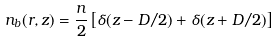Convert formula to latex. <formula><loc_0><loc_0><loc_500><loc_500>n _ { b } ( { r } , z ) = \frac { n } { 2 } \left [ \delta ( z - D / 2 ) + \delta ( z + D / 2 ) \right ]</formula> 